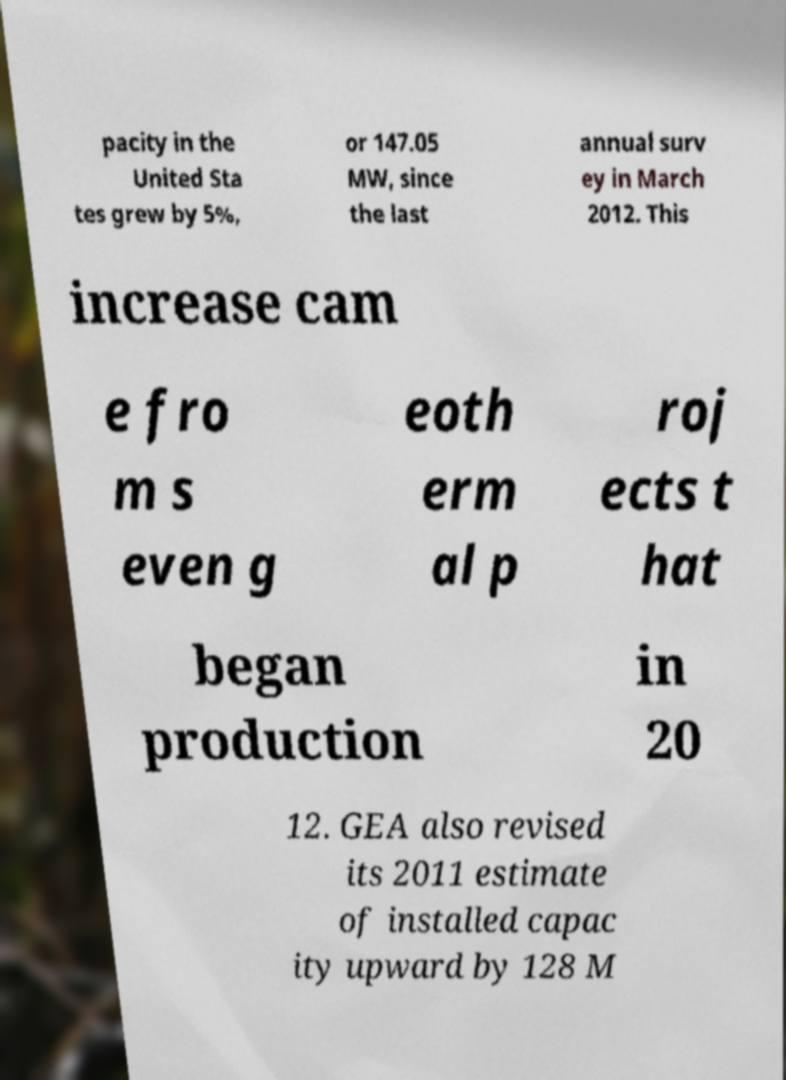Could you assist in decoding the text presented in this image and type it out clearly? pacity in the United Sta tes grew by 5%, or 147.05 MW, since the last annual surv ey in March 2012. This increase cam e fro m s even g eoth erm al p roj ects t hat began production in 20 12. GEA also revised its 2011 estimate of installed capac ity upward by 128 M 